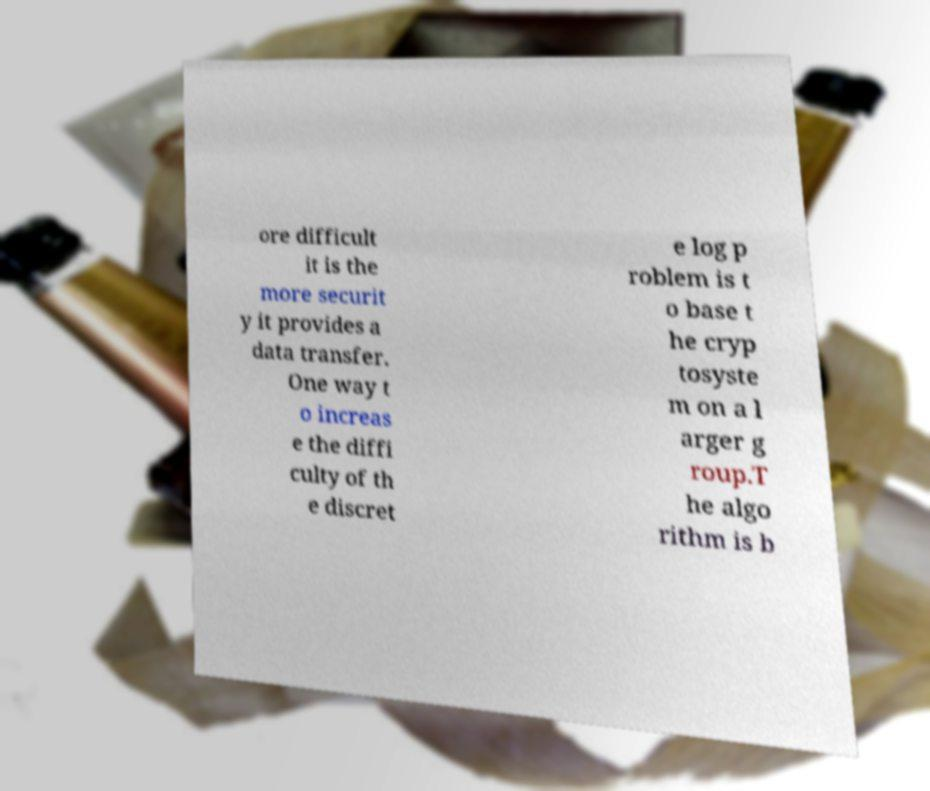I need the written content from this picture converted into text. Can you do that? ore difficult it is the more securit y it provides a data transfer. One way t o increas e the diffi culty of th e discret e log p roblem is t o base t he cryp tosyste m on a l arger g roup.T he algo rithm is b 